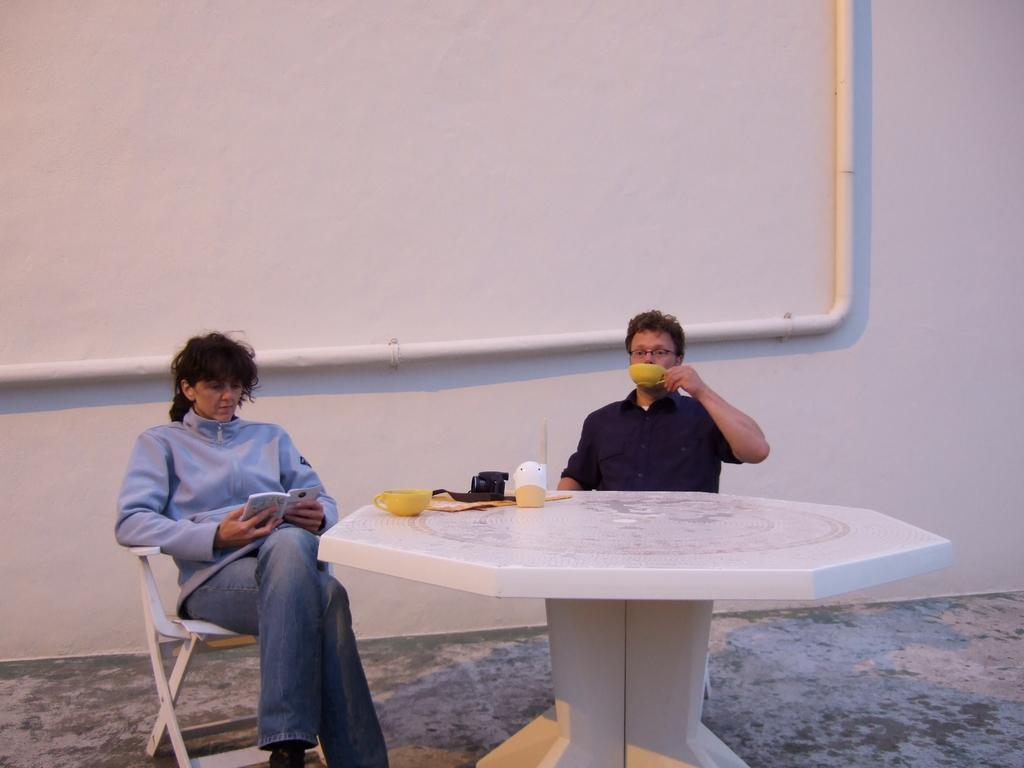How many people are in the image? There are two people in the image. What are the two people doing in the image? The two people are sitting on chairs. What type of shock does the snail receive in the image? There is no snail present in the image, so it cannot receive any shock. 